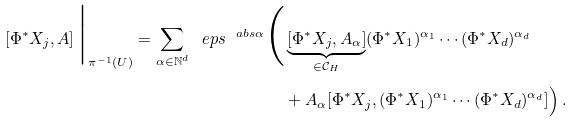<formula> <loc_0><loc_0><loc_500><loc_500>\left [ \Phi ^ { * } X _ { j } , A \right ] \Big | _ { \pi ^ { - 1 } ( U ) } = \sum _ { \alpha \in \mathbb { N } ^ { d } } \ e p s ^ { \ a b s { \alpha } } \Big ( & \underbrace { [ \Phi ^ { * } X _ { j } , A _ { \alpha } ] } _ { \in \mathcal { C } _ { H } } ( \Phi ^ { * } X _ { 1 } ) ^ { \alpha _ { 1 } } \cdots ( \Phi ^ { * } X _ { d } ) ^ { \alpha _ { d } } \\ & + A _ { \alpha } [ \Phi ^ { * } X _ { j } , ( \Phi ^ { * } X _ { 1 } ) ^ { \alpha _ { 1 } } \cdots ( \Phi ^ { * } X _ { d } ) ^ { \alpha _ { d } } ] \Big ) \, .</formula> 